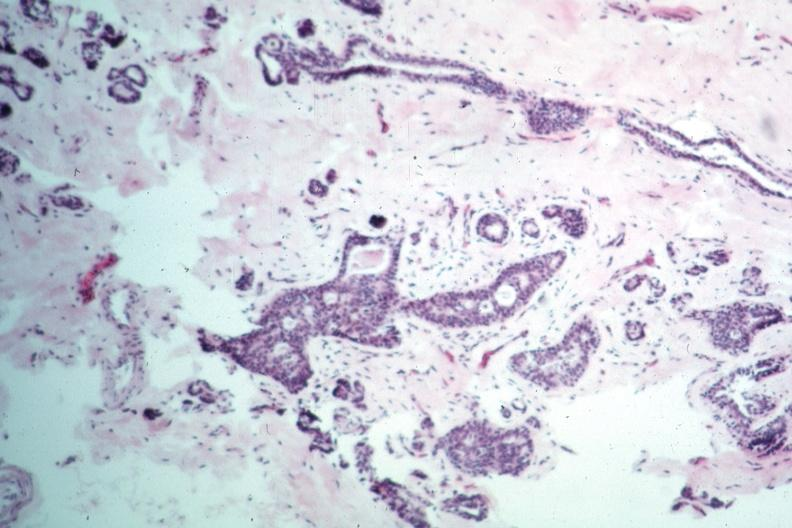s intraductal papillomatosis present?
Answer the question using a single word or phrase. Yes 